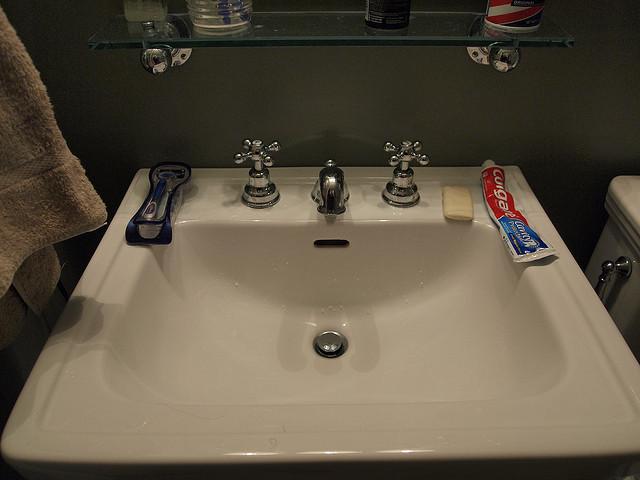Is there a toothbrush?
Answer briefly. No. Is the faucet on?
Short answer required. No. What brand of toothpaste is visible?
Write a very short answer. Colgate. 